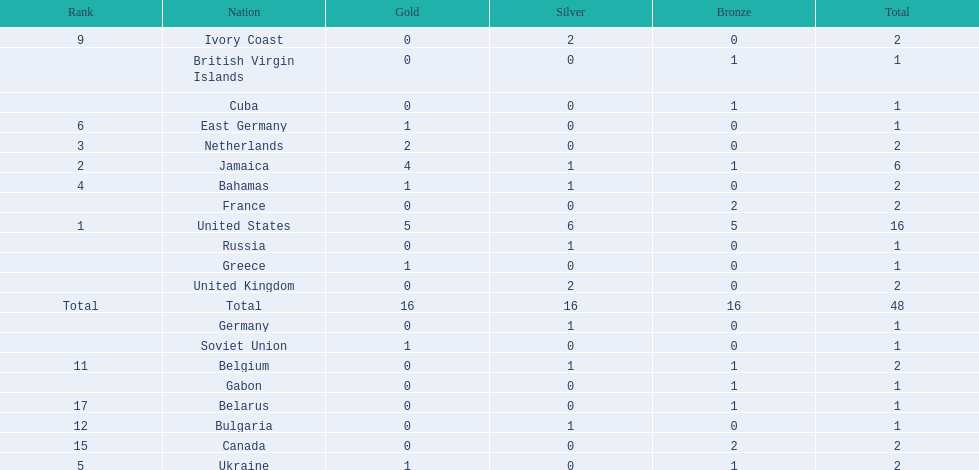Parse the full table. {'header': ['Rank', 'Nation', 'Gold', 'Silver', 'Bronze', 'Total'], 'rows': [['9', 'Ivory Coast', '0', '2', '0', '2'], ['', 'British Virgin Islands', '0', '0', '1', '1'], ['', 'Cuba', '0', '0', '1', '1'], ['6', 'East Germany', '1', '0', '0', '1'], ['3', 'Netherlands', '2', '0', '0', '2'], ['2', 'Jamaica', '4', '1', '1', '6'], ['4', 'Bahamas', '1', '1', '0', '2'], ['', 'France', '0', '0', '2', '2'], ['1', 'United States', '5', '6', '5', '16'], ['', 'Russia', '0', '1', '0', '1'], ['', 'Greece', '1', '0', '0', '1'], ['', 'United Kingdom', '0', '2', '0', '2'], ['Total', 'Total', '16', '16', '16', '48'], ['', 'Germany', '0', '1', '0', '1'], ['', 'Soviet Union', '1', '0', '0', '1'], ['11', 'Belgium', '0', '1', '1', '2'], ['', 'Gabon', '0', '0', '1', '1'], ['17', 'Belarus', '0', '0', '1', '1'], ['12', 'Bulgaria', '0', '1', '0', '1'], ['15', 'Canada', '0', '0', '2', '2'], ['5', 'Ukraine', '1', '0', '1', '2']]} What country won the most medals? United States. How many medals did the us win? 16. What is the most medals (after 16) that were won by a country? 6. Which country won 6 medals? Jamaica. 